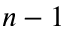<formula> <loc_0><loc_0><loc_500><loc_500>n - 1</formula> 